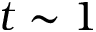<formula> <loc_0><loc_0><loc_500><loc_500>t \sim 1</formula> 